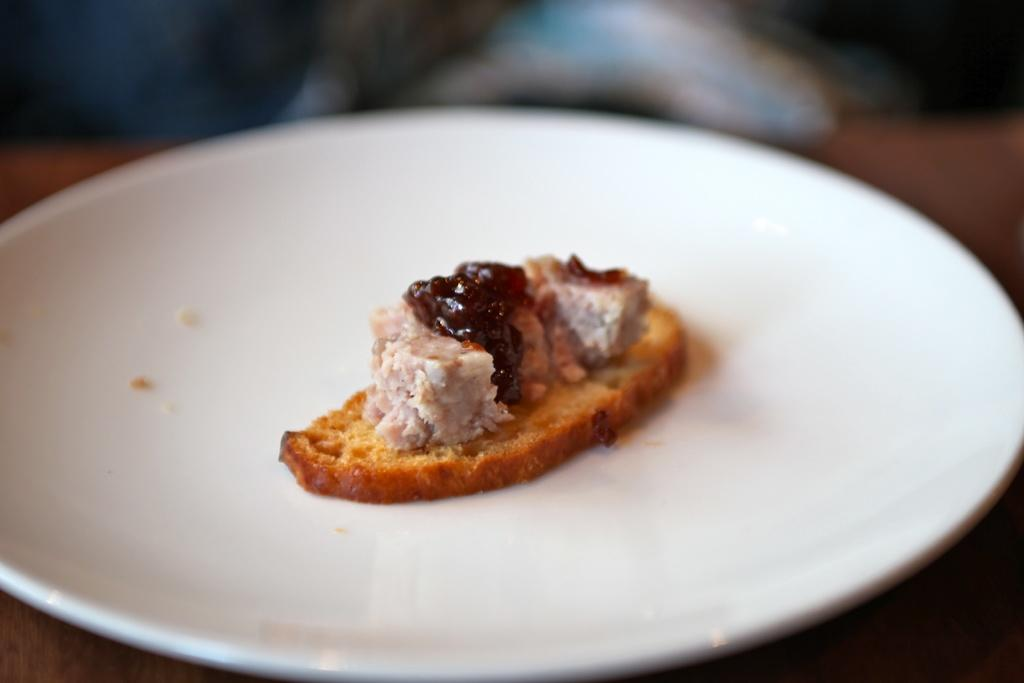What color is the plate that is visible in the image? The plate is white. What is on the plate in the image? There is a food item on the white plate. What type of ball is visible on the plate in the image? There is no ball present on the plate in the image; it only contains a food item. 